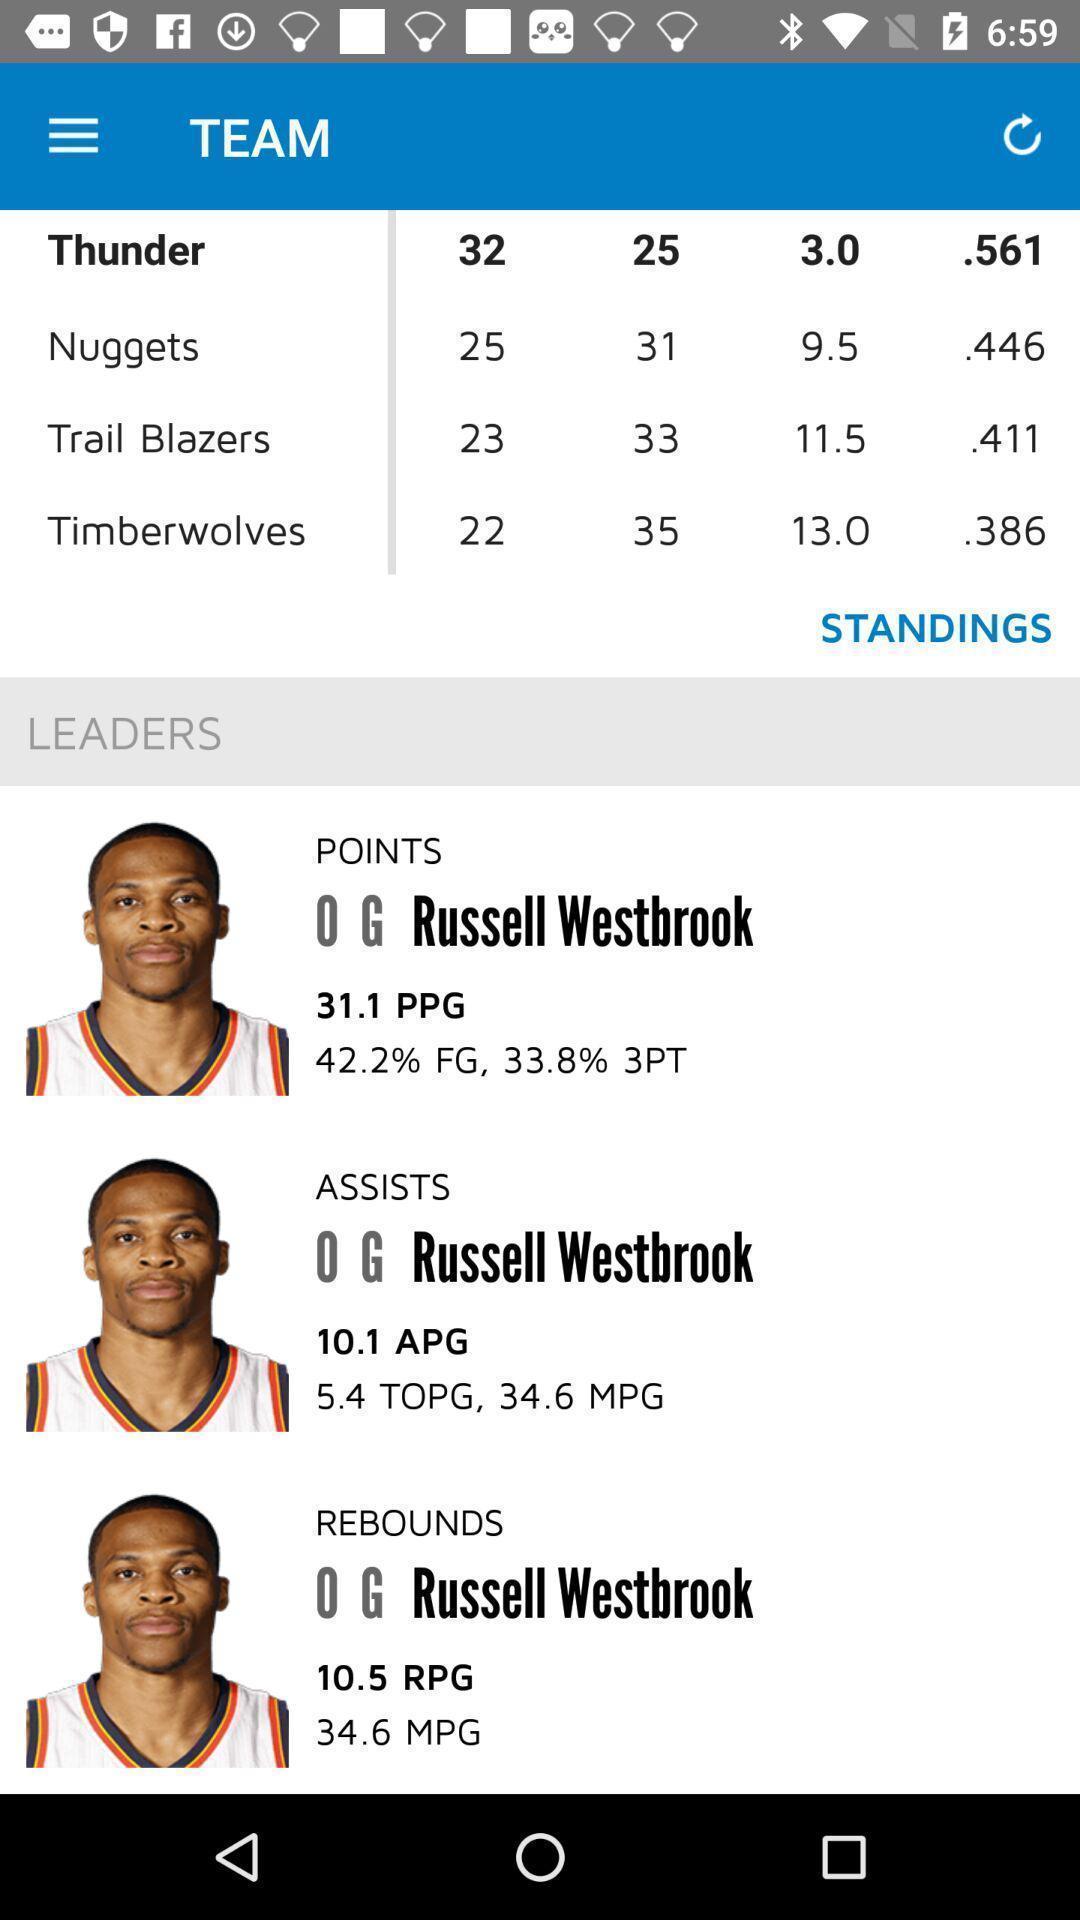What details can you identify in this image? Window displaying a live scorer app. 